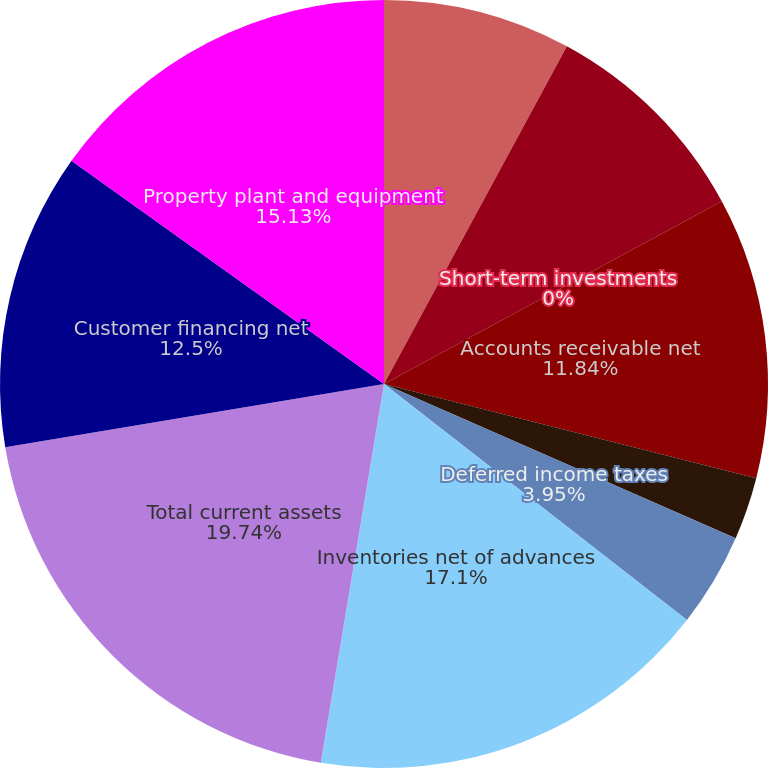Convert chart to OTSL. <chart><loc_0><loc_0><loc_500><loc_500><pie_chart><fcel>(Dollars in millions except<fcel>Cash and cash equivalents<fcel>Short-term investments<fcel>Accounts receivable net<fcel>Current portion of customer<fcel>Deferred income taxes<fcel>Inventories net of advances<fcel>Total current assets<fcel>Customer financing net<fcel>Property plant and equipment<nl><fcel>7.9%<fcel>9.21%<fcel>0.0%<fcel>11.84%<fcel>2.63%<fcel>3.95%<fcel>17.1%<fcel>19.74%<fcel>12.5%<fcel>15.13%<nl></chart> 